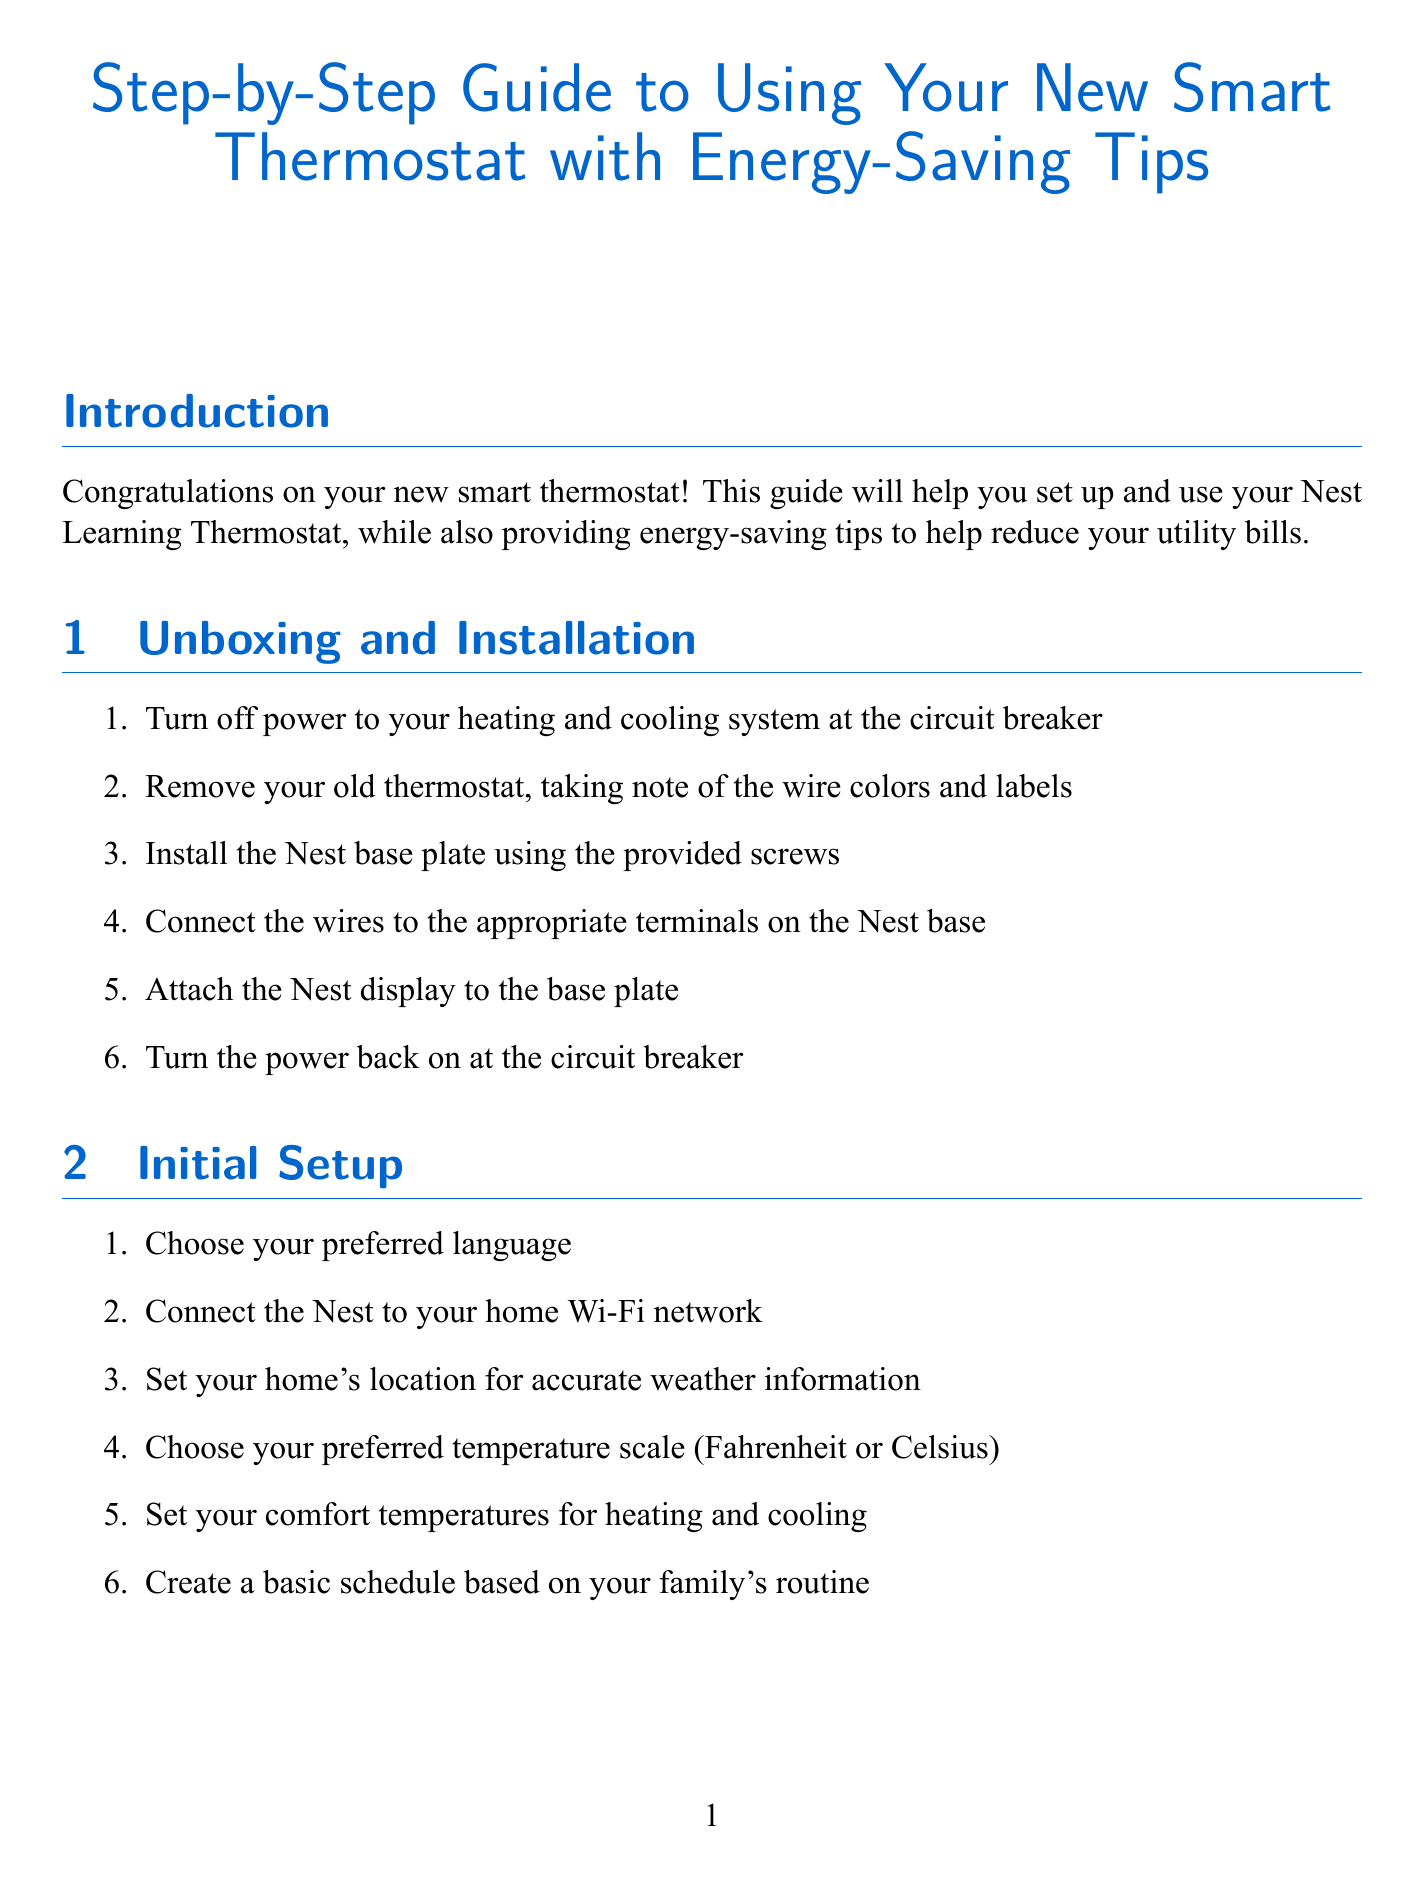What is the title of the guide? The title of the guide is found at the top of the document.
Answer: Step-by-Step Guide to Using Your New Smart Thermostat with Energy-Saving Tips How many steps are there in the unboxing and installation section? The unboxing and installation section contains a list of steps used for installation.
Answer: 6 What temperature change is suggested when sleeping or away from home? The energy-saving tips offer specific temperature adjustments for when you are not at home.
Answer: 7-10 degrees lower What feature allows the thermostat to learn your preferences? This term references a specific function in the basic operation section of the thermostat.
Answer: Auto-Schedule What action should you take if the thermostat is not connecting to Wi-Fi? This is a common troubleshooting step provided in the troubleshooting section.
Answer: Ensure your Wi-Fi password is correct and your router is functioning properly What is the purpose of the Nest Leaf feature? The document describes features that help with energy efficiency.
Answer: Guide for energy-efficient settings 